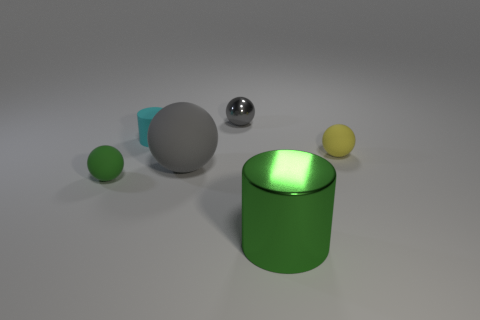There is a tiny matte thing that is in front of the large matte thing; is it the same color as the large shiny cylinder?
Offer a very short reply. Yes. How many cubes are small red metal things or big shiny objects?
Your answer should be compact. 0. There is a matte thing on the right side of the large gray matte object; what shape is it?
Provide a succinct answer. Sphere. There is a rubber ball that is on the right side of the green object to the right of the gray sphere that is to the right of the large gray rubber thing; what is its color?
Keep it short and to the point. Yellow. Are the small yellow ball and the small gray object made of the same material?
Offer a very short reply. No. How many green objects are rubber cylinders or shiny cylinders?
Make the answer very short. 1. What number of balls are behind the small yellow matte thing?
Your answer should be compact. 1. Is the number of large matte balls greater than the number of small purple matte cylinders?
Your response must be concise. Yes. There is a small matte thing behind the small rubber sphere behind the tiny green ball; what is its shape?
Ensure brevity in your answer.  Cylinder. Does the large rubber ball have the same color as the big cylinder?
Your response must be concise. No. 